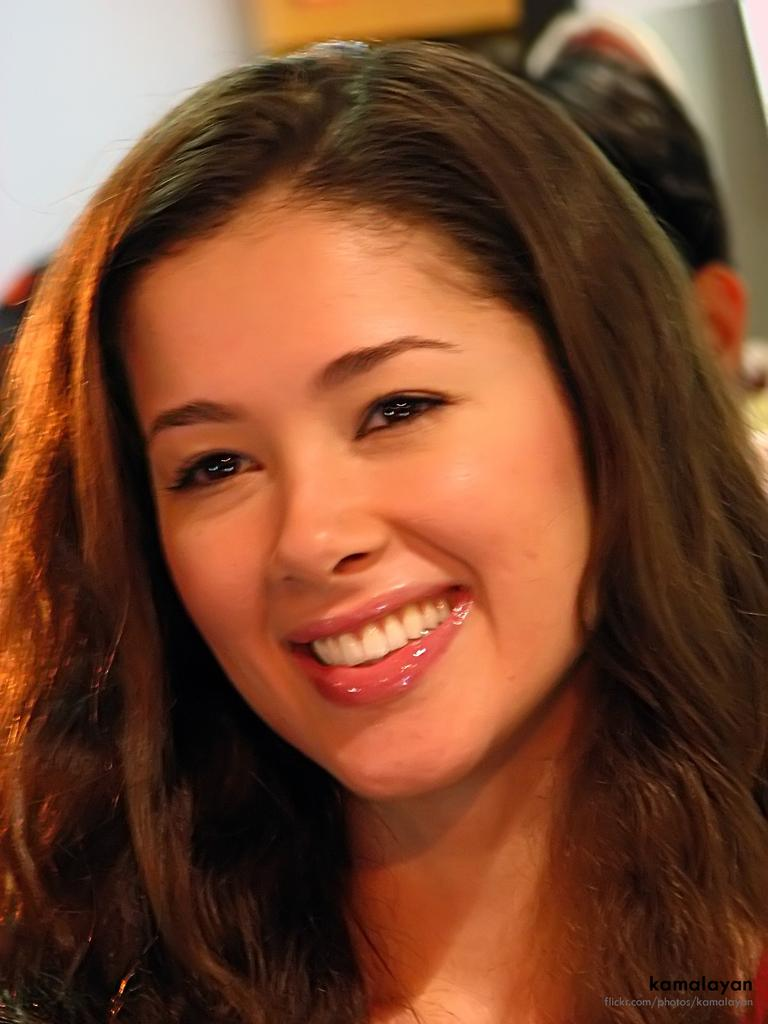Who is present in the image? There is a lady in the image. What is the lady doing in the image? The lady is smiling in the image. What type of circle can be seen in the image? There is no circle present in the image. How does the lady sail in the image? The lady is not sailing in the image; she is simply smiling. 